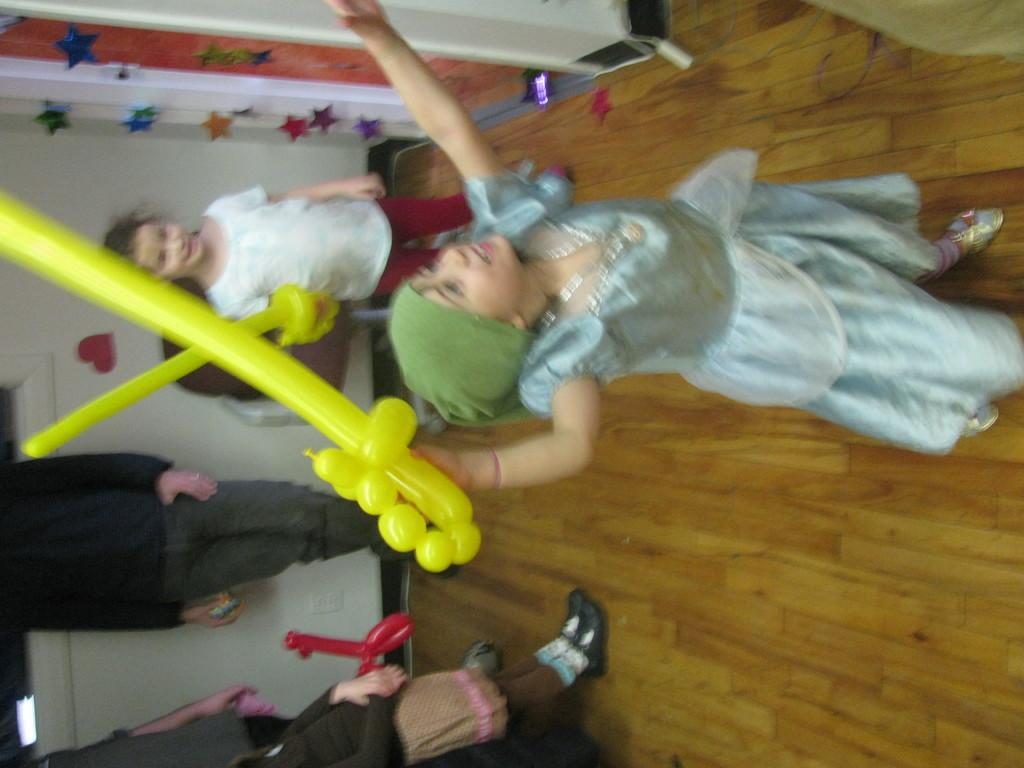How many kids are visible in the image? There are two kids standing in the image. What are the kids holding in their hands? The kids are holding yellow objects in their hands. Are there any other people visible in the image? Yes, there are other people standing in the left corner of the image. What type of road can be seen in the image? There is no road visible in the image. How many snails are crawling on the yellow objects held by the kids? There are no snails present in the image. 